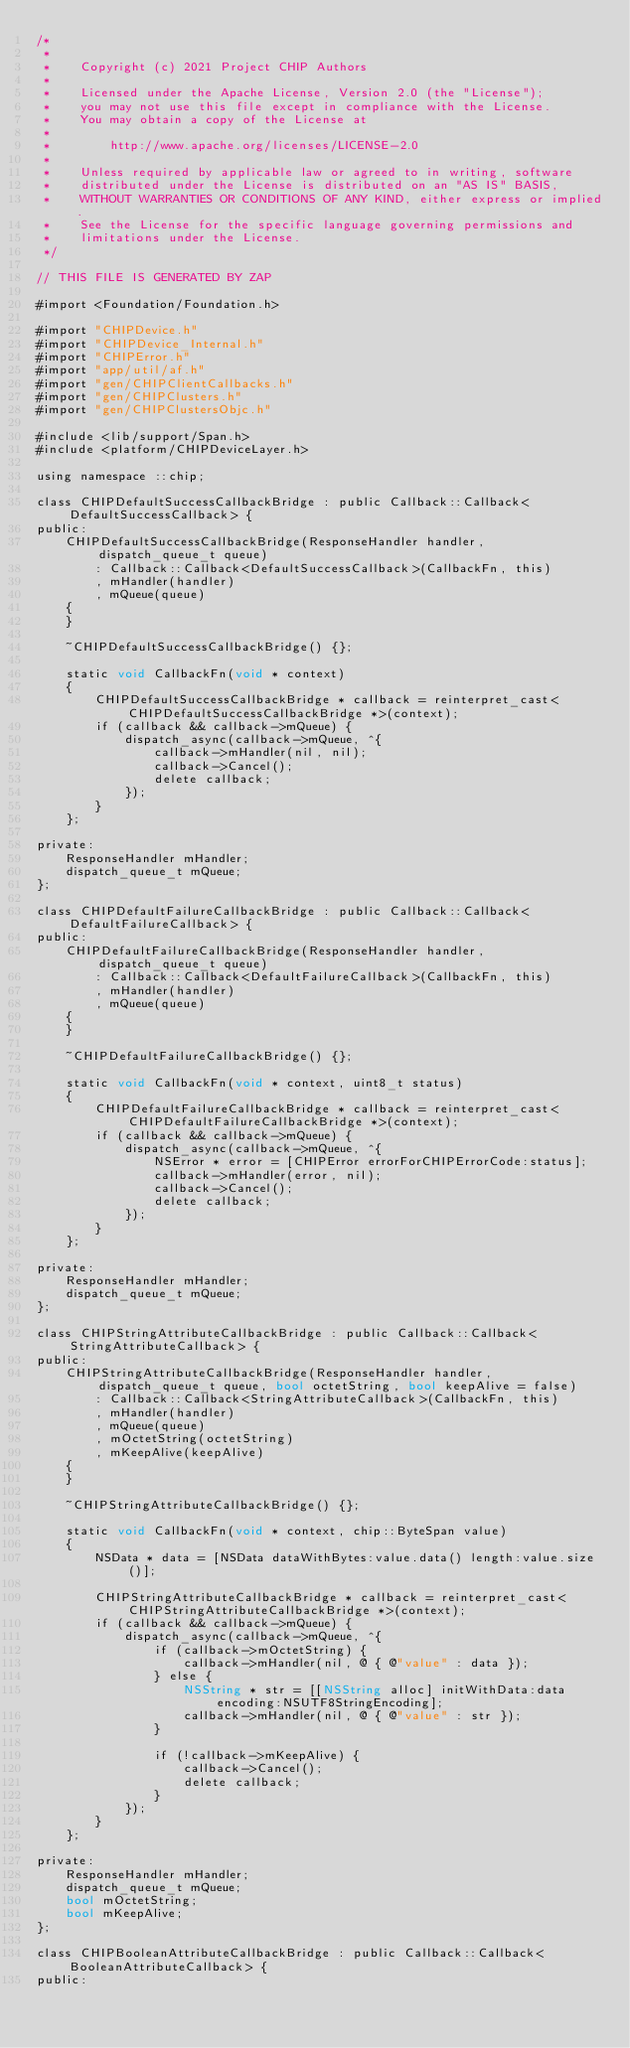<code> <loc_0><loc_0><loc_500><loc_500><_ObjectiveC_>/*
 *
 *    Copyright (c) 2021 Project CHIP Authors
 *
 *    Licensed under the Apache License, Version 2.0 (the "License");
 *    you may not use this file except in compliance with the License.
 *    You may obtain a copy of the License at
 *
 *        http://www.apache.org/licenses/LICENSE-2.0
 *
 *    Unless required by applicable law or agreed to in writing, software
 *    distributed under the License is distributed on an "AS IS" BASIS,
 *    WITHOUT WARRANTIES OR CONDITIONS OF ANY KIND, either express or implied.
 *    See the License for the specific language governing permissions and
 *    limitations under the License.
 */

// THIS FILE IS GENERATED BY ZAP

#import <Foundation/Foundation.h>

#import "CHIPDevice.h"
#import "CHIPDevice_Internal.h"
#import "CHIPError.h"
#import "app/util/af.h"
#import "gen/CHIPClientCallbacks.h"
#import "gen/CHIPClusters.h"
#import "gen/CHIPClustersObjc.h"

#include <lib/support/Span.h>
#include <platform/CHIPDeviceLayer.h>

using namespace ::chip;

class CHIPDefaultSuccessCallbackBridge : public Callback::Callback<DefaultSuccessCallback> {
public:
    CHIPDefaultSuccessCallbackBridge(ResponseHandler handler, dispatch_queue_t queue)
        : Callback::Callback<DefaultSuccessCallback>(CallbackFn, this)
        , mHandler(handler)
        , mQueue(queue)
    {
    }

    ~CHIPDefaultSuccessCallbackBridge() {};

    static void CallbackFn(void * context)
    {
        CHIPDefaultSuccessCallbackBridge * callback = reinterpret_cast<CHIPDefaultSuccessCallbackBridge *>(context);
        if (callback && callback->mQueue) {
            dispatch_async(callback->mQueue, ^{
                callback->mHandler(nil, nil);
                callback->Cancel();
                delete callback;
            });
        }
    };

private:
    ResponseHandler mHandler;
    dispatch_queue_t mQueue;
};

class CHIPDefaultFailureCallbackBridge : public Callback::Callback<DefaultFailureCallback> {
public:
    CHIPDefaultFailureCallbackBridge(ResponseHandler handler, dispatch_queue_t queue)
        : Callback::Callback<DefaultFailureCallback>(CallbackFn, this)
        , mHandler(handler)
        , mQueue(queue)
    {
    }

    ~CHIPDefaultFailureCallbackBridge() {};

    static void CallbackFn(void * context, uint8_t status)
    {
        CHIPDefaultFailureCallbackBridge * callback = reinterpret_cast<CHIPDefaultFailureCallbackBridge *>(context);
        if (callback && callback->mQueue) {
            dispatch_async(callback->mQueue, ^{
                NSError * error = [CHIPError errorForCHIPErrorCode:status];
                callback->mHandler(error, nil);
                callback->Cancel();
                delete callback;
            });
        }
    };

private:
    ResponseHandler mHandler;
    dispatch_queue_t mQueue;
};

class CHIPStringAttributeCallbackBridge : public Callback::Callback<StringAttributeCallback> {
public:
    CHIPStringAttributeCallbackBridge(ResponseHandler handler, dispatch_queue_t queue, bool octetString, bool keepAlive = false)
        : Callback::Callback<StringAttributeCallback>(CallbackFn, this)
        , mHandler(handler)
        , mQueue(queue)
        , mOctetString(octetString)
        , mKeepAlive(keepAlive)
    {
    }

    ~CHIPStringAttributeCallbackBridge() {};

    static void CallbackFn(void * context, chip::ByteSpan value)
    {
        NSData * data = [NSData dataWithBytes:value.data() length:value.size()];

        CHIPStringAttributeCallbackBridge * callback = reinterpret_cast<CHIPStringAttributeCallbackBridge *>(context);
        if (callback && callback->mQueue) {
            dispatch_async(callback->mQueue, ^{
                if (callback->mOctetString) {
                    callback->mHandler(nil, @ { @"value" : data });
                } else {
                    NSString * str = [[NSString alloc] initWithData:data encoding:NSUTF8StringEncoding];
                    callback->mHandler(nil, @ { @"value" : str });
                }

                if (!callback->mKeepAlive) {
                    callback->Cancel();
                    delete callback;
                }
            });
        }
    };

private:
    ResponseHandler mHandler;
    dispatch_queue_t mQueue;
    bool mOctetString;
    bool mKeepAlive;
};

class CHIPBooleanAttributeCallbackBridge : public Callback::Callback<BooleanAttributeCallback> {
public:</code> 